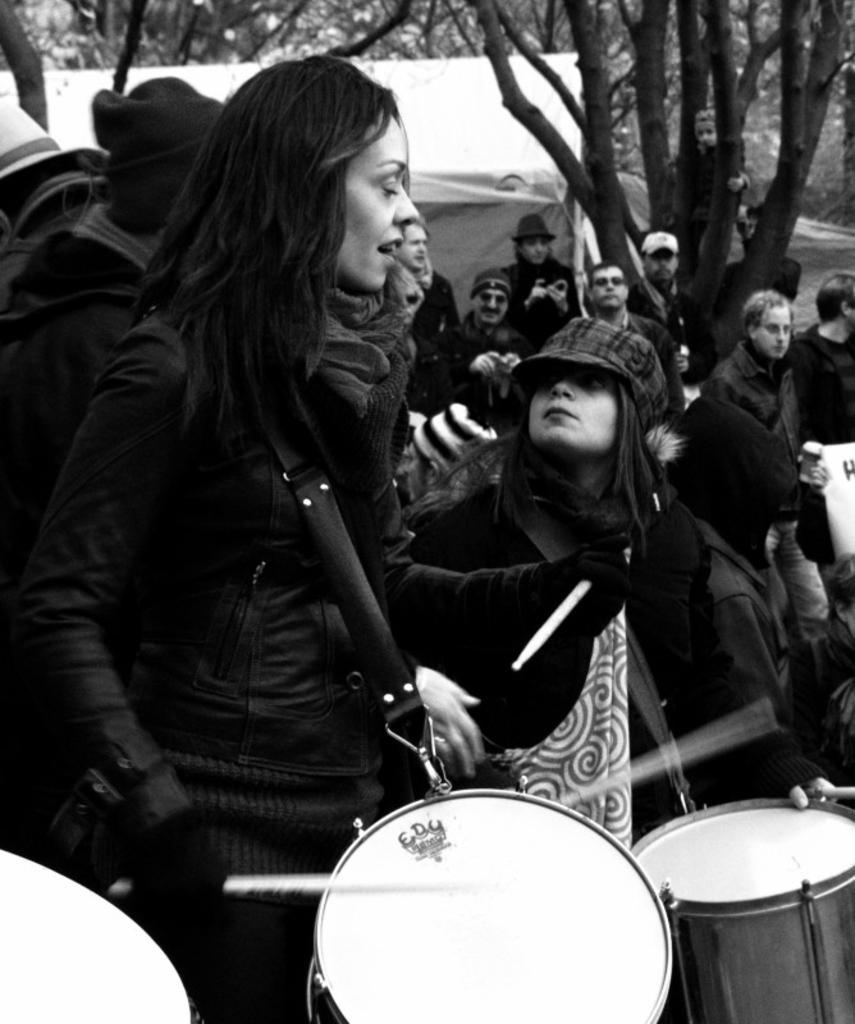In one or two sentences, can you explain what this image depicts? In this image I can see the group of people. Among them some people are holding the drums. In the background there is a tent and the trees. 